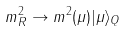<formula> <loc_0><loc_0><loc_500><loc_500>m ^ { 2 } _ { R } \rightarrow m ^ { 2 } ( \mu ) | \mu \rangle _ { Q }</formula> 